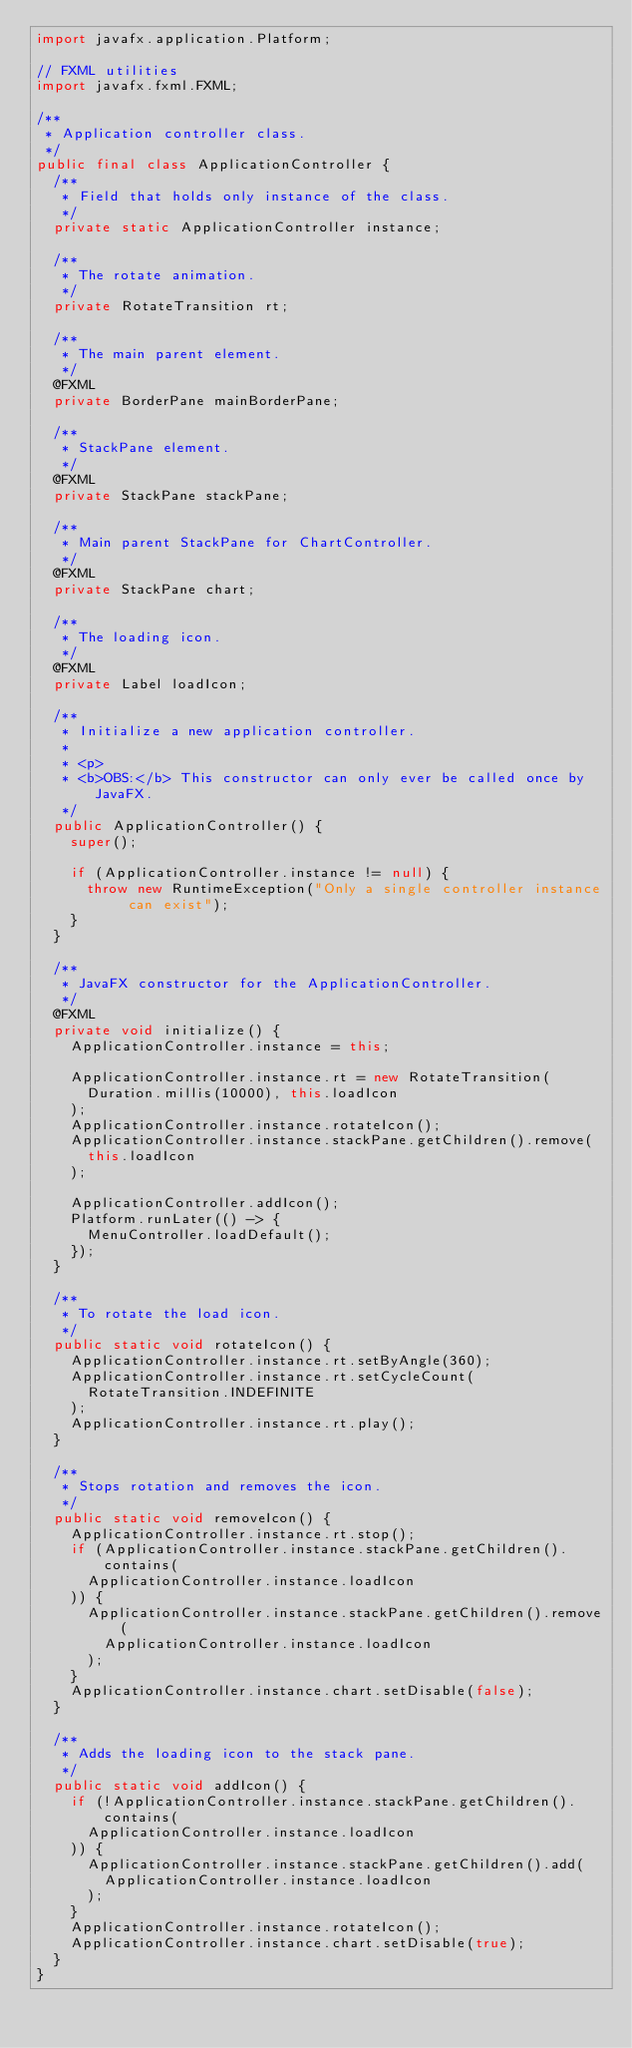<code> <loc_0><loc_0><loc_500><loc_500><_Java_>import javafx.application.Platform;

// FXML utilities
import javafx.fxml.FXML;

/**
 * Application controller class.
 */
public final class ApplicationController {
  /**
   * Field that holds only instance of the class.
   */
  private static ApplicationController instance;

  /**
   * The rotate animation.
   */
  private RotateTransition rt;

  /**
   * The main parent element.
   */
  @FXML
  private BorderPane mainBorderPane;

  /**
   * StackPane element.
   */
  @FXML
  private StackPane stackPane;

  /**
   * Main parent StackPane for ChartController.
   */
  @FXML
  private StackPane chart;

  /**
   * The loading icon.
   */
  @FXML
  private Label loadIcon;

  /**
   * Initialize a new application controller.
   *
   * <p>
   * <b>OBS:</b> This constructor can only ever be called once by JavaFX.
   */
  public ApplicationController() {
    super();

    if (ApplicationController.instance != null) {
      throw new RuntimeException("Only a single controller instance can exist");
    }
  }

  /**
   * JavaFX constructor for the ApplicationController.
   */
  @FXML
  private void initialize() {
    ApplicationController.instance = this;

    ApplicationController.instance.rt = new RotateTransition(
      Duration.millis(10000), this.loadIcon
    );
    ApplicationController.instance.rotateIcon();
    ApplicationController.instance.stackPane.getChildren().remove(
      this.loadIcon
    );

    ApplicationController.addIcon();
    Platform.runLater(() -> {
      MenuController.loadDefault();
    });
  }

  /**
   * To rotate the load icon.
   */
  public static void rotateIcon() {
    ApplicationController.instance.rt.setByAngle(360);
    ApplicationController.instance.rt.setCycleCount(
      RotateTransition.INDEFINITE
    );
    ApplicationController.instance.rt.play();
  }

  /**
   * Stops rotation and removes the icon.
   */
  public static void removeIcon() {
    ApplicationController.instance.rt.stop();
    if (ApplicationController.instance.stackPane.getChildren().contains(
      ApplicationController.instance.loadIcon
    )) {
      ApplicationController.instance.stackPane.getChildren().remove(
        ApplicationController.instance.loadIcon
      );
    }
    ApplicationController.instance.chart.setDisable(false);
  }

  /**
   * Adds the loading icon to the stack pane.
   */
  public static void addIcon() {
    if (!ApplicationController.instance.stackPane.getChildren().contains(
      ApplicationController.instance.loadIcon
    )) {
      ApplicationController.instance.stackPane.getChildren().add(
        ApplicationController.instance.loadIcon
      );
    }
    ApplicationController.instance.rotateIcon();
    ApplicationController.instance.chart.setDisable(true);
  }
}
</code> 